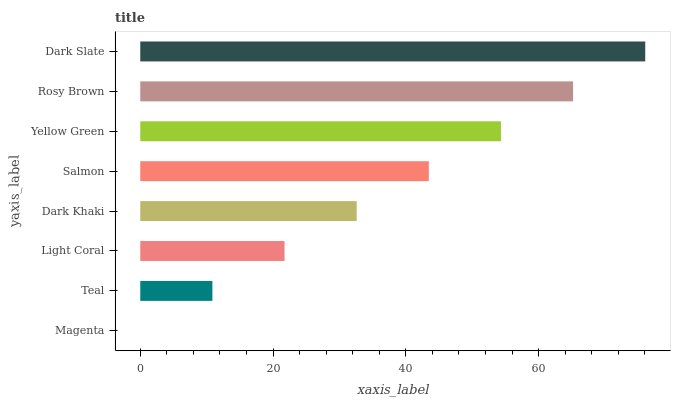Is Magenta the minimum?
Answer yes or no. Yes. Is Dark Slate the maximum?
Answer yes or no. Yes. Is Teal the minimum?
Answer yes or no. No. Is Teal the maximum?
Answer yes or no. No. Is Teal greater than Magenta?
Answer yes or no. Yes. Is Magenta less than Teal?
Answer yes or no. Yes. Is Magenta greater than Teal?
Answer yes or no. No. Is Teal less than Magenta?
Answer yes or no. No. Is Salmon the high median?
Answer yes or no. Yes. Is Dark Khaki the low median?
Answer yes or no. Yes. Is Dark Slate the high median?
Answer yes or no. No. Is Salmon the low median?
Answer yes or no. No. 